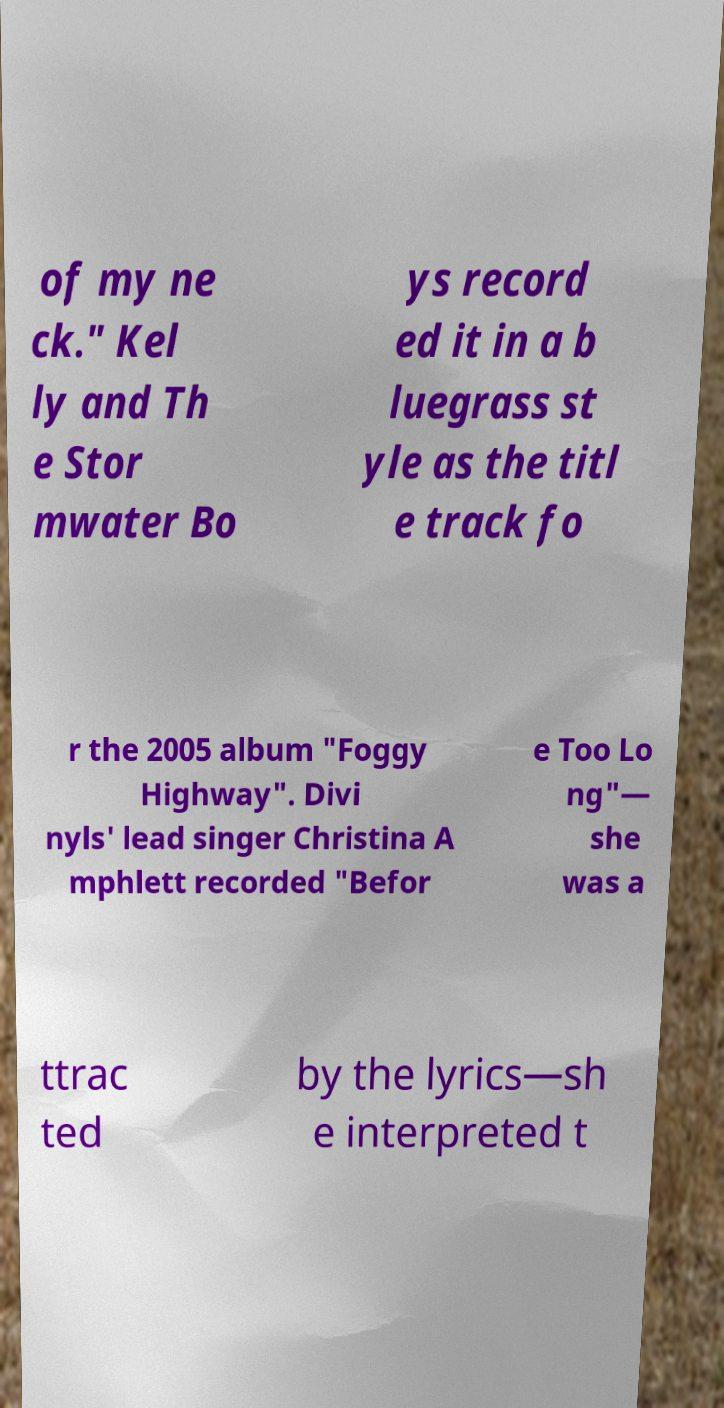Please read and relay the text visible in this image. What does it say? of my ne ck." Kel ly and Th e Stor mwater Bo ys record ed it in a b luegrass st yle as the titl e track fo r the 2005 album "Foggy Highway". Divi nyls' lead singer Christina A mphlett recorded "Befor e Too Lo ng"— she was a ttrac ted by the lyrics—sh e interpreted t 